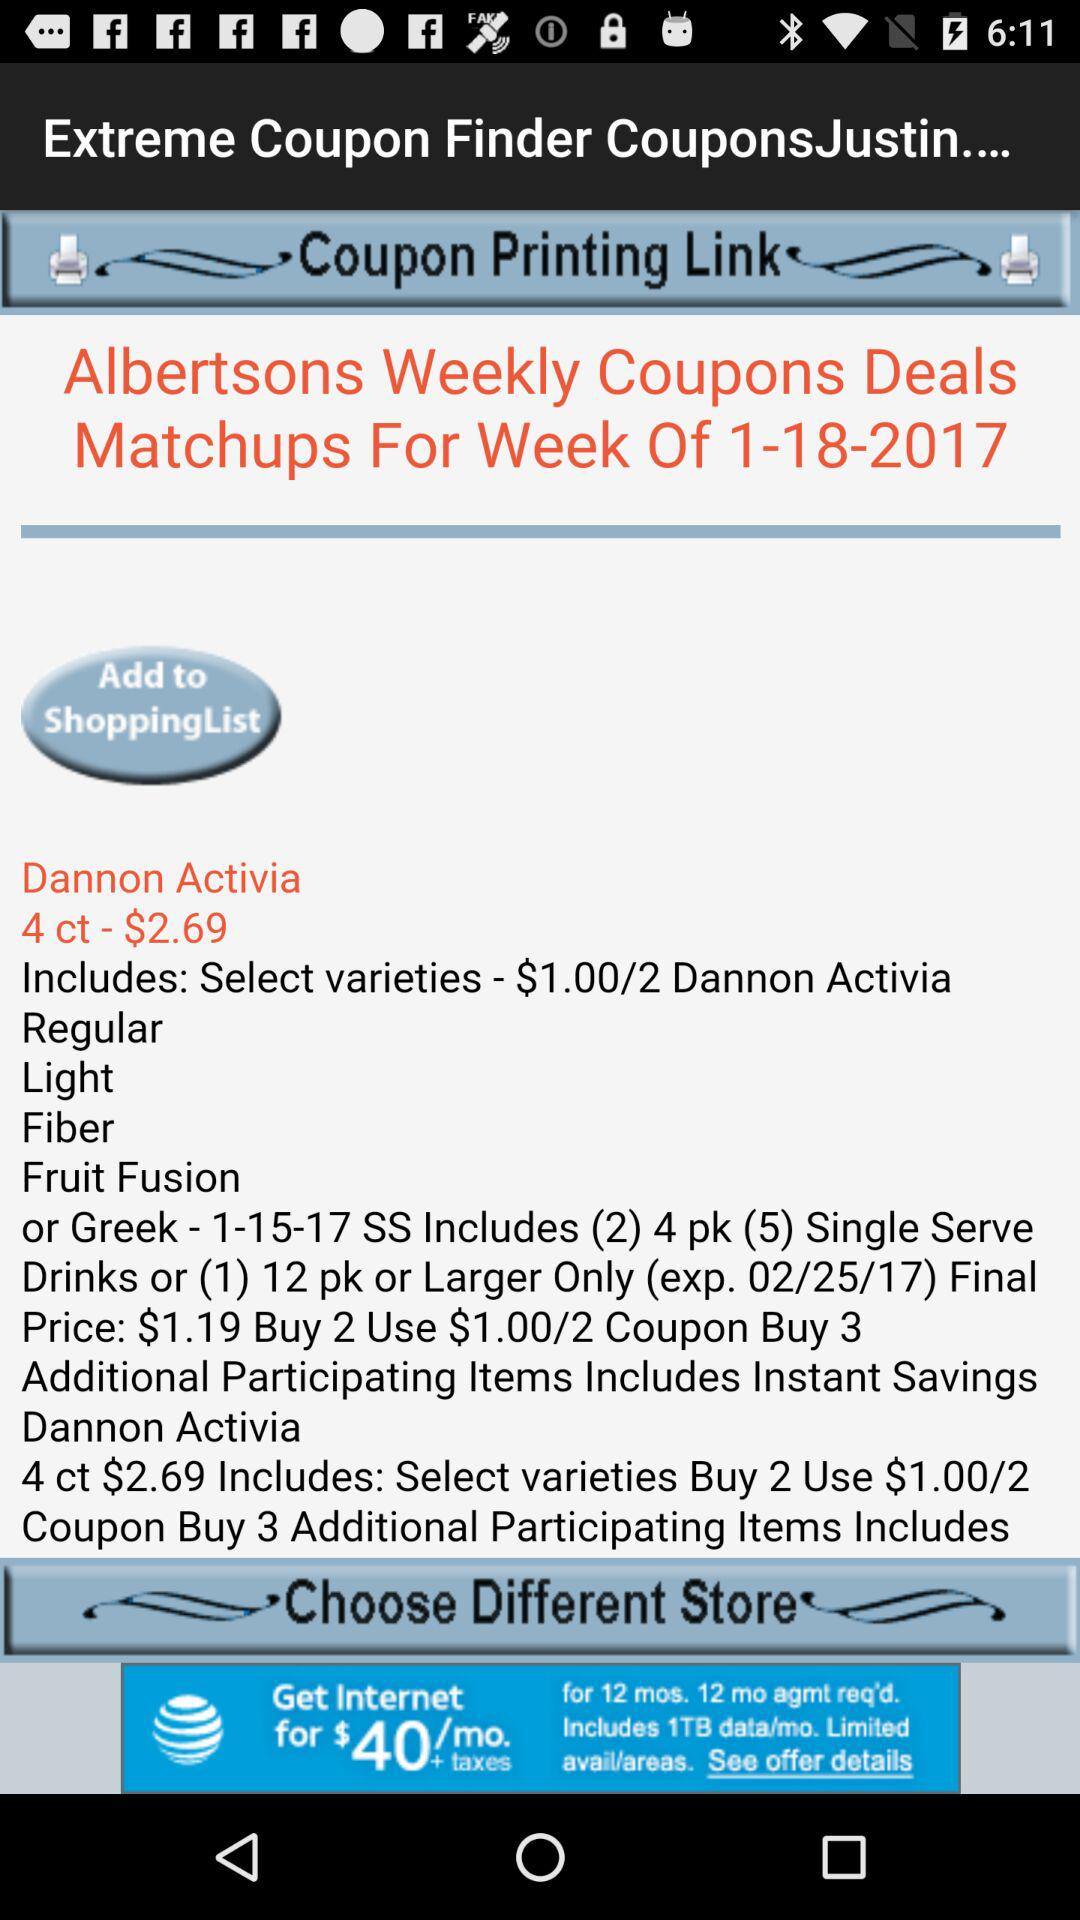What are the varieties included in Dannon Activia 4 ct? The varieties are "Regular", "Light", "Fiber" and "Fruit Fusion". 